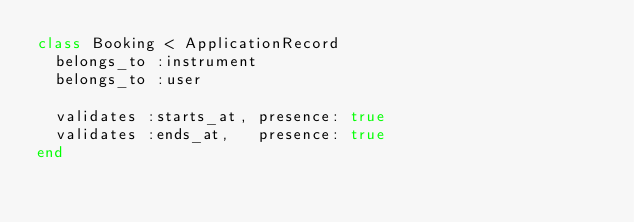<code> <loc_0><loc_0><loc_500><loc_500><_Ruby_>class Booking < ApplicationRecord
  belongs_to :instrument
  belongs_to :user

  validates :starts_at, presence: true
  validates :ends_at,   presence: true
end
</code> 